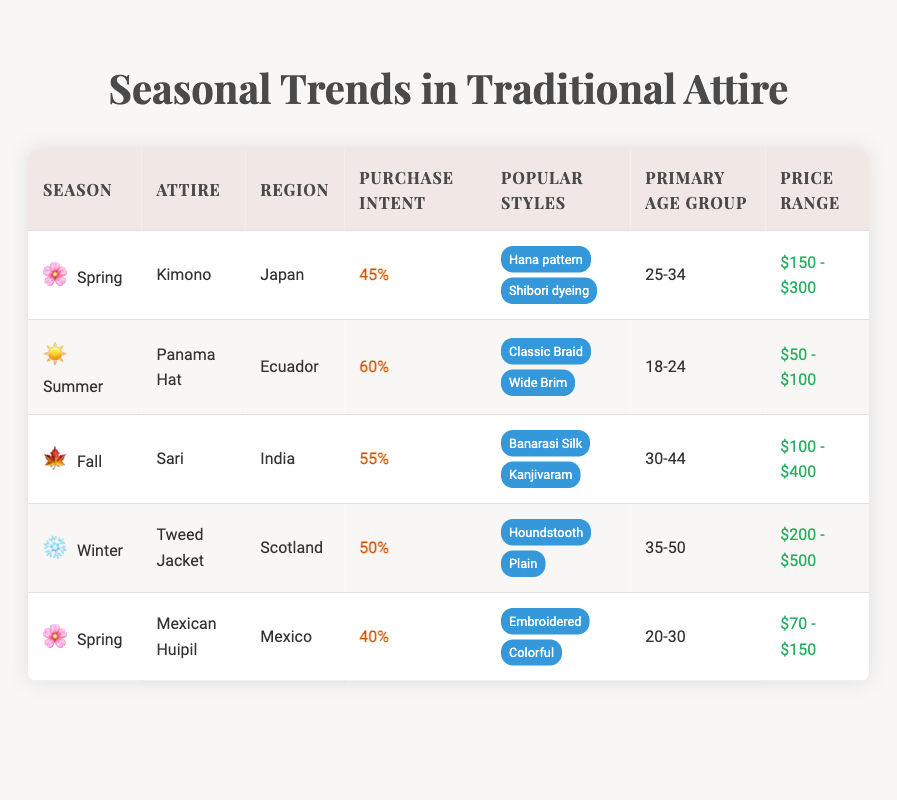What is the purchase intent percentage for the Sari in Fall? The table lists the "Sari" under the Fall season with a corresponding "purchase intent percentage" of 55%.
Answer: 55% Which traditional attire has the highest purchase intent percentage? By comparing the purchase intent percentages across all attire listed in the table, the "Panama Hat" has the highest percentage at 60%.
Answer: Panama Hat What is the primary age group for the Tweed Jacket? The "Tweed Jacket", associated with Scotland in the Winter season, is targeted towards the primary age group of 35-50 years.
Answer: 35-50 How much higher is the purchase intent percentage for the Panama Hat compared to the Kimono? The Panama Hat has a purchase intent percentage of 60%, while the Kimono has a percentage of 45%. Subtracting 45 from 60 gives a difference of 15%.
Answer: 15% Is the price range for the Mexican Huipil higher than that for the Kimono? The price range for the Mexican Huipil is $70 - $150, while the price range for the Kimono is $150 - $300. Since $150 is higher than $150, the statement is false.
Answer: No Which attire is popular among the 20-30 age group and what are its popular styles? The "Mexican Huipil" is the only attire listed under the 20-30 age group, with popular styles being "Embroidered" and "Colorful".
Answer: Mexican Huipil, Embroidered and Colorful If a consumer spends between $100 and $200, which attires could they purchase? The "Sari" has a price range of $100 - $400, and the "Mexican Huipil" falls within $70 - $150. The consumer can purchase the Sari as it's within the overall range they can afford.
Answer: Sari and Mexican Huipil What is the average purchase intent percentage across all seasons for traditional attire? The purchase intent percentages are 45, 60, 55, 50, and 40. The sum is 250, and dividing by the number of entries (5) gives an average of 50%.
Answer: 50% Which region's traditional attire is aimed at the youngest primary age group? The Panama Hat is aimed at the 18-24 age group from Ecuador, which is the youngest age group among the attires listed in the table.
Answer: Ecuador 